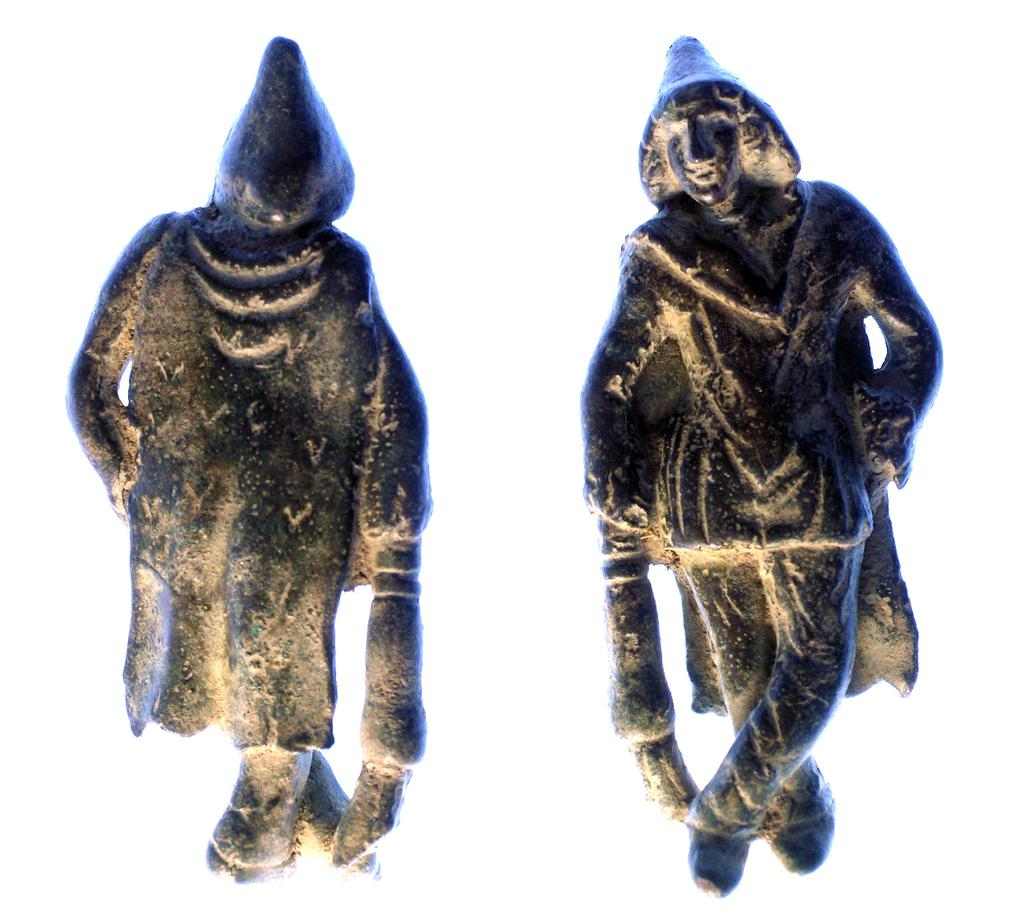How many sculptures are present in the image? There are two sculptures in the image. Can you describe the positioning of the sculptures in relation to each other? The first sculpture appears to be in the background of the second sculpture. What type of monkey can be seen climbing on the second sculpture in the image? There are no monkeys present in the image; it features two sculptures. 